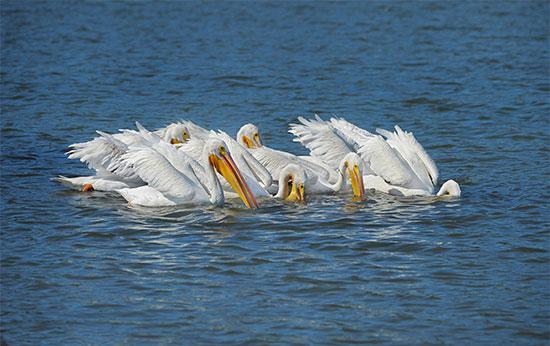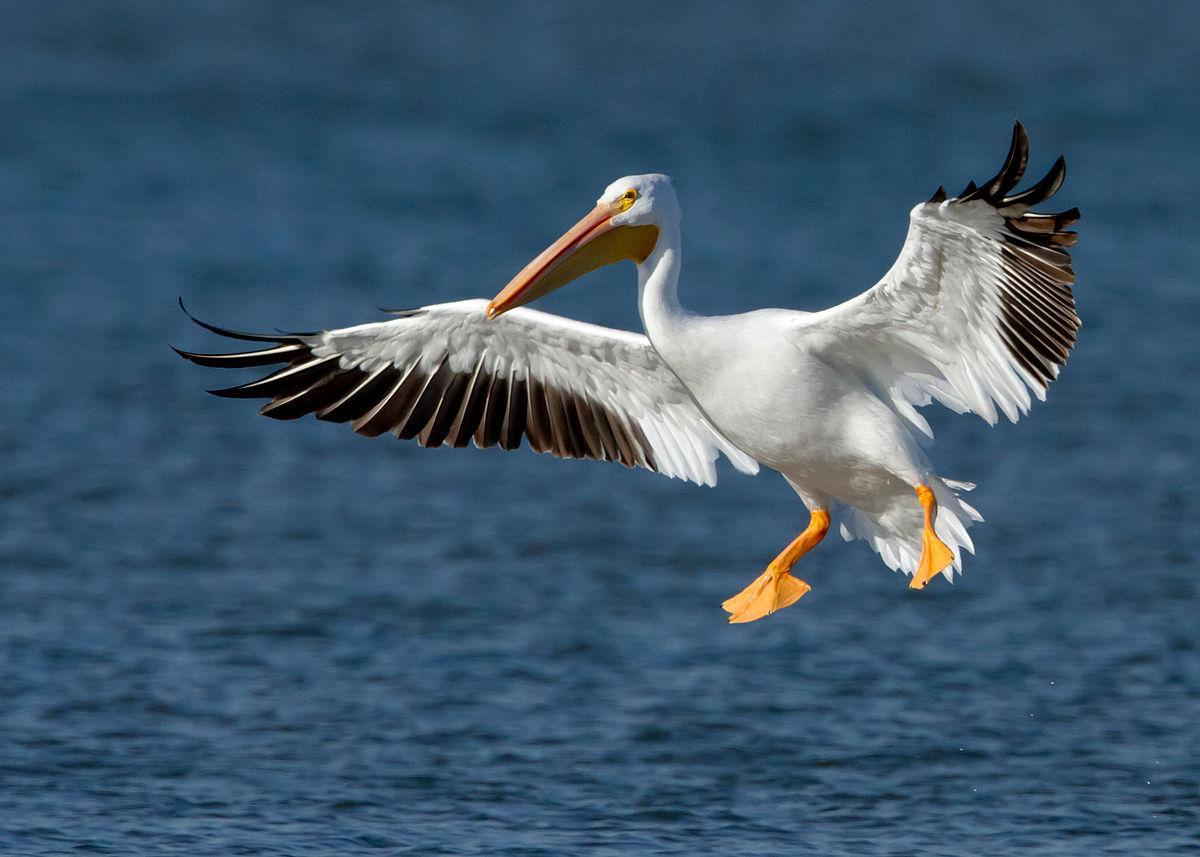The first image is the image on the left, the second image is the image on the right. Given the left and right images, does the statement "There is one bird flying in the picture on the right." hold true? Answer yes or no. Yes. 